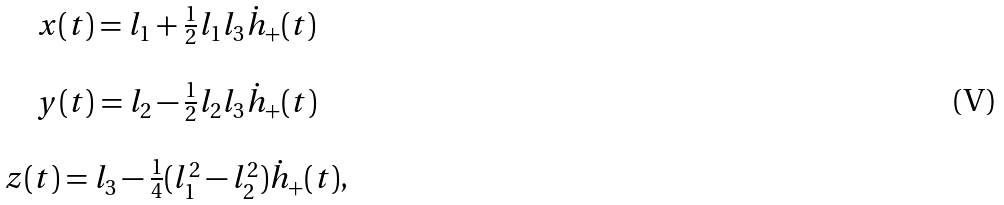Convert formula to latex. <formula><loc_0><loc_0><loc_500><loc_500>\begin{array} { c } x ( t ) = l _ { 1 } + \frac { 1 } { 2 } l _ { 1 } l _ { 3 } \dot { h } _ { + } ( t ) \\ \\ y ( t ) = l _ { 2 } - \frac { 1 } { 2 } l _ { 2 } l _ { 3 } \dot { h } _ { + } ( t ) \\ \\ z ( t ) = l _ { 3 } - \frac { 1 } { 4 } ( l _ { 1 } ^ { 2 } - l _ { 2 } ^ { 2 } ) \dot { h } _ { + } ( t ) , \end{array}</formula> 